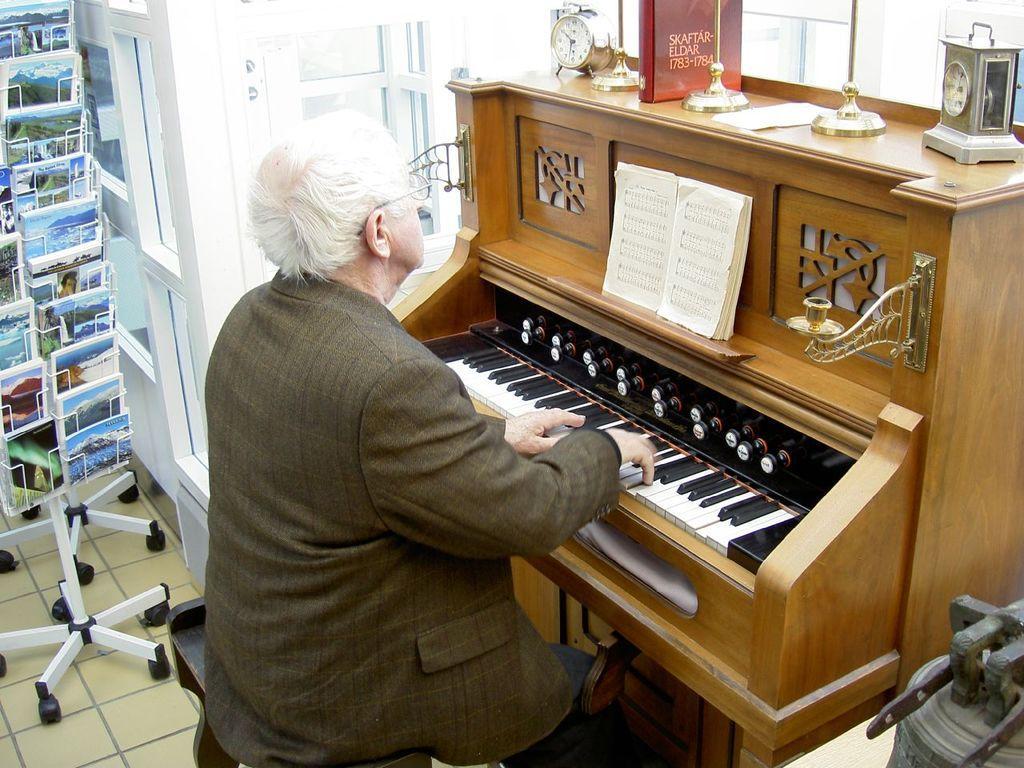Please provide a concise description of this image. In the image we can see there is a man who is sitting and playing piano. 